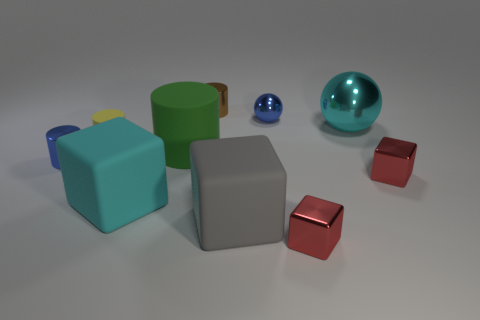Subtract all small yellow cylinders. How many cylinders are left? 3 Subtract all brown cylinders. How many cylinders are left? 3 Subtract all blue balls. How many red cubes are left? 2 Subtract all cylinders. How many objects are left? 6 Subtract 2 cylinders. How many cylinders are left? 2 Subtract all purple spheres. Subtract all cyan cylinders. How many spheres are left? 2 Add 9 yellow objects. How many yellow objects are left? 10 Add 4 cyan balls. How many cyan balls exist? 5 Subtract 1 brown cylinders. How many objects are left? 9 Subtract all small brown cubes. Subtract all tiny blue metallic things. How many objects are left? 8 